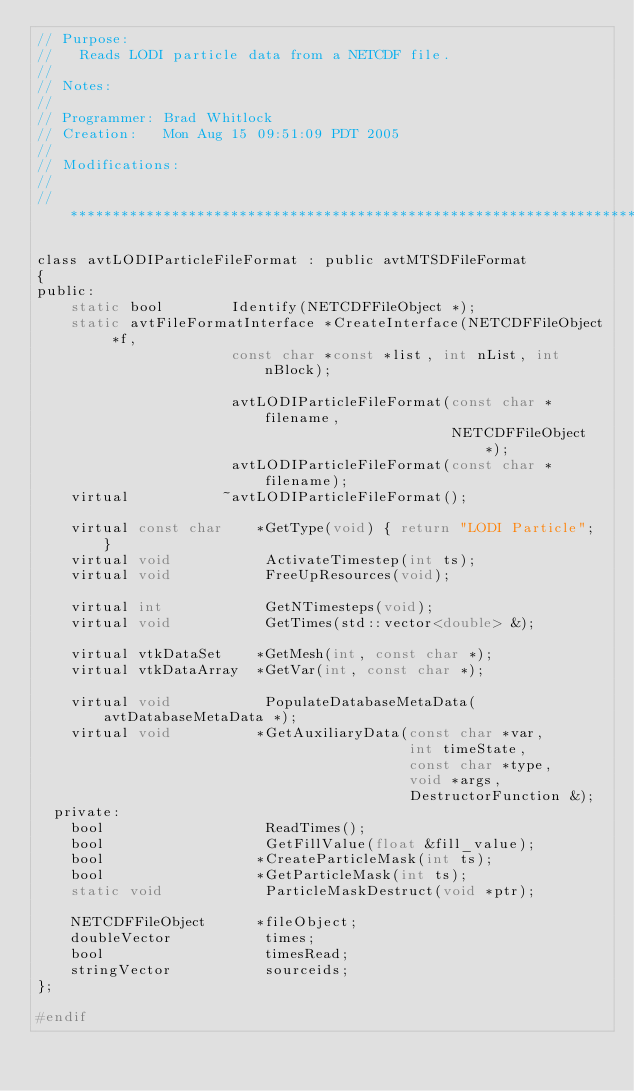Convert code to text. <code><loc_0><loc_0><loc_500><loc_500><_C_>// Purpose:
//   Reads LODI particle data from a NETCDF file.
//
// Notes:      
//
// Programmer: Brad Whitlock
// Creation:   Mon Aug 15 09:51:09 PDT 2005
//
// Modifications:
//   
// ****************************************************************************

class avtLODIParticleFileFormat : public avtMTSDFileFormat
{
public:
    static bool        Identify(NETCDFFileObject *);
    static avtFileFormatInterface *CreateInterface(NETCDFFileObject *f,
                       const char *const *list, int nList, int nBlock);

                       avtLODIParticleFileFormat(const char *filename,
                                                 NETCDFFileObject *);
                       avtLODIParticleFileFormat(const char *filename);
    virtual           ~avtLODIParticleFileFormat();

    virtual const char    *GetType(void) { return "LODI Particle"; }
    virtual void           ActivateTimestep(int ts);
    virtual void           FreeUpResources(void);

    virtual int            GetNTimesteps(void);
    virtual void           GetTimes(std::vector<double> &);

    virtual vtkDataSet    *GetMesh(int, const char *);
    virtual vtkDataArray  *GetVar(int, const char *);

    virtual void           PopulateDatabaseMetaData(avtDatabaseMetaData *);
    virtual void          *GetAuxiliaryData(const char *var,
                                            int timeState,
                                            const char *type,
                                            void *args,
                                            DestructorFunction &);
  private:
    bool                   ReadTimes();
    bool                   GetFillValue(float &fill_value);
    bool                  *CreateParticleMask(int ts);
    bool                  *GetParticleMask(int ts);
    static void            ParticleMaskDestruct(void *ptr);

    NETCDFFileObject      *fileObject;
    doubleVector           times;
    bool                   timesRead;
    stringVector           sourceids;
};

#endif
</code> 